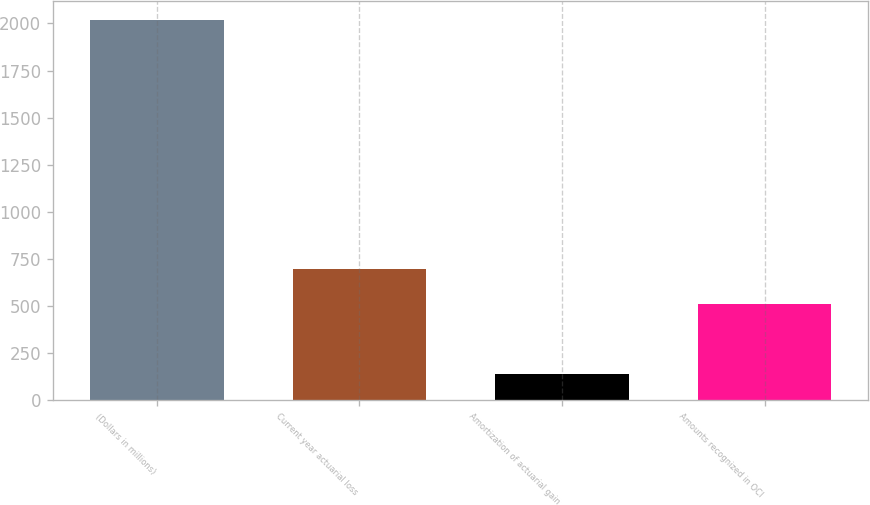Convert chart to OTSL. <chart><loc_0><loc_0><loc_500><loc_500><bar_chart><fcel>(Dollars in millions)<fcel>Current year actuarial loss<fcel>Amortization of actuarial gain<fcel>Amounts recognized in OCI<nl><fcel>2016<fcel>696.7<fcel>139<fcel>509<nl></chart> 